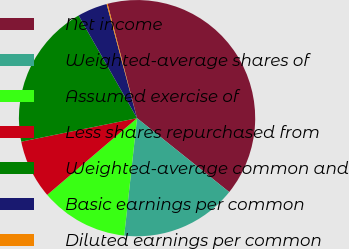Convert chart. <chart><loc_0><loc_0><loc_500><loc_500><pie_chart><fcel>Net income<fcel>Weighted-average shares of<fcel>Assumed exercise of<fcel>Less shares repurchased from<fcel>Weighted-average common and<fcel>Basic earnings per common<fcel>Diluted earnings per common<nl><fcel>39.77%<fcel>15.98%<fcel>12.02%<fcel>8.06%<fcel>19.95%<fcel>4.09%<fcel>0.13%<nl></chart> 